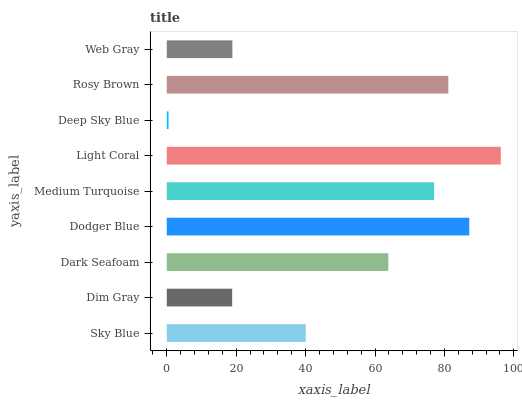Is Deep Sky Blue the minimum?
Answer yes or no. Yes. Is Light Coral the maximum?
Answer yes or no. Yes. Is Dim Gray the minimum?
Answer yes or no. No. Is Dim Gray the maximum?
Answer yes or no. No. Is Sky Blue greater than Dim Gray?
Answer yes or no. Yes. Is Dim Gray less than Sky Blue?
Answer yes or no. Yes. Is Dim Gray greater than Sky Blue?
Answer yes or no. No. Is Sky Blue less than Dim Gray?
Answer yes or no. No. Is Dark Seafoam the high median?
Answer yes or no. Yes. Is Dark Seafoam the low median?
Answer yes or no. Yes. Is Sky Blue the high median?
Answer yes or no. No. Is Sky Blue the low median?
Answer yes or no. No. 